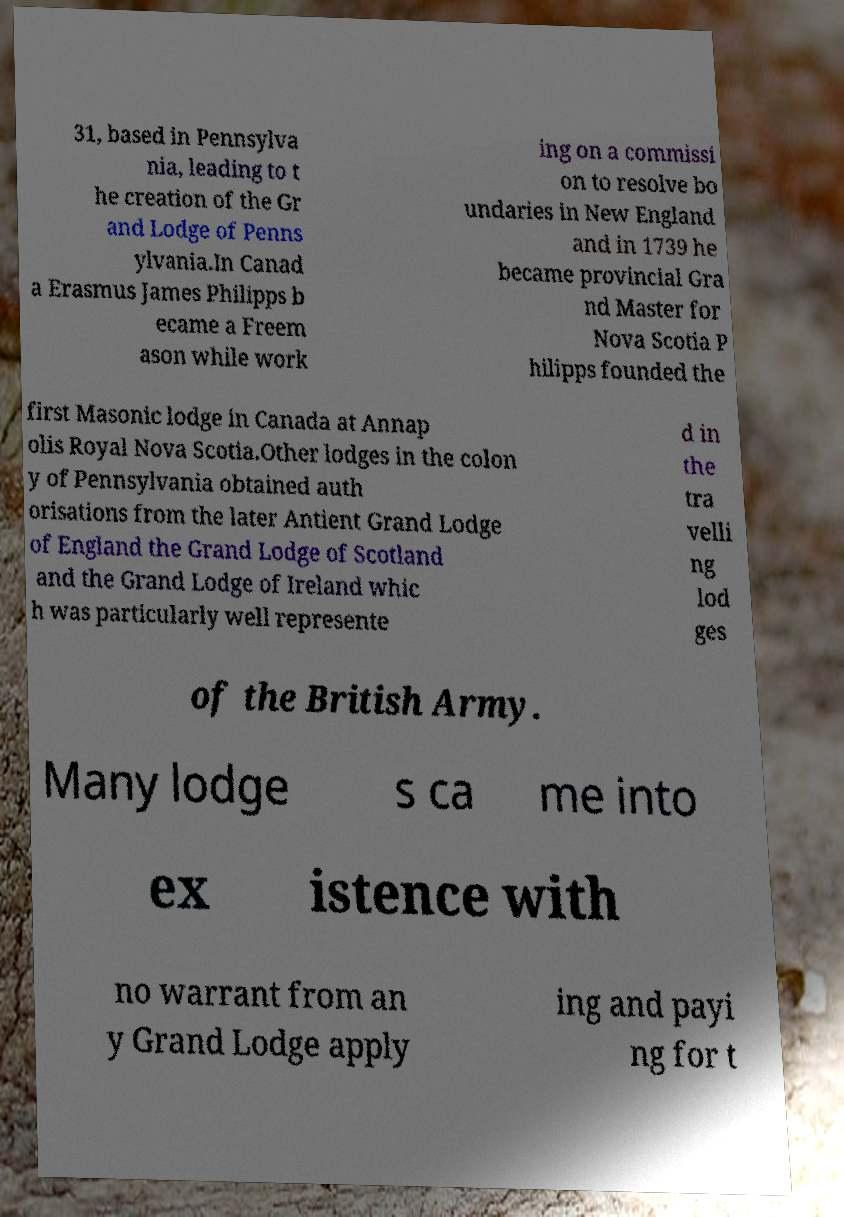Please read and relay the text visible in this image. What does it say? 31, based in Pennsylva nia, leading to t he creation of the Gr and Lodge of Penns ylvania.In Canad a Erasmus James Philipps b ecame a Freem ason while work ing on a commissi on to resolve bo undaries in New England and in 1739 he became provincial Gra nd Master for Nova Scotia P hilipps founded the first Masonic lodge in Canada at Annap olis Royal Nova Scotia.Other lodges in the colon y of Pennsylvania obtained auth orisations from the later Antient Grand Lodge of England the Grand Lodge of Scotland and the Grand Lodge of Ireland whic h was particularly well represente d in the tra velli ng lod ges of the British Army. Many lodge s ca me into ex istence with no warrant from an y Grand Lodge apply ing and payi ng for t 